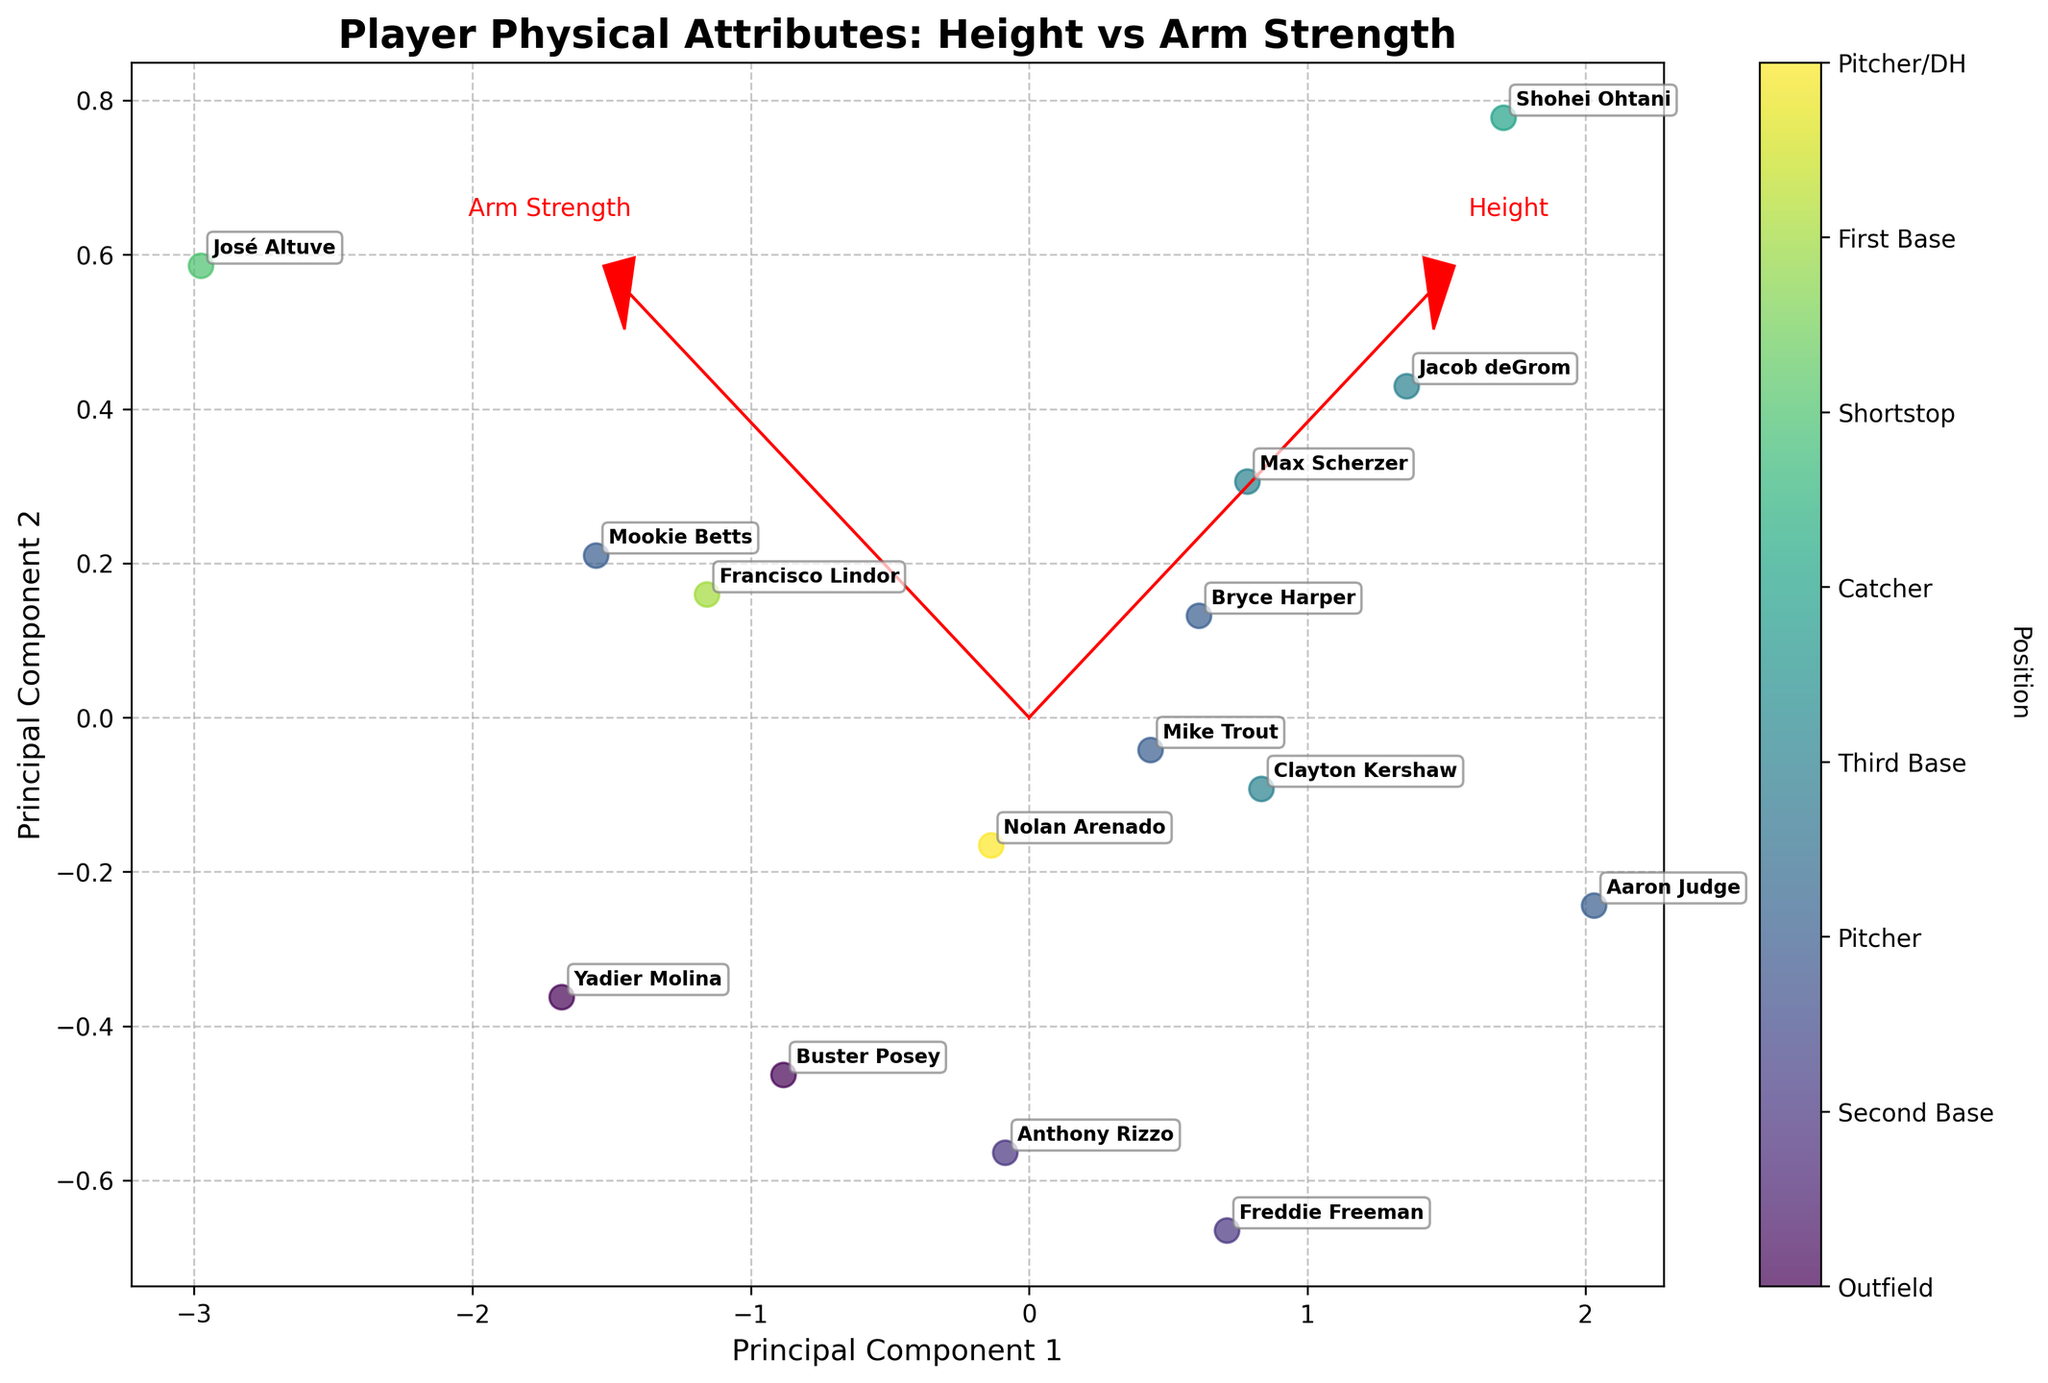What's the title of the figure? The title of the figure is always shown at the top of the plot. In this case, it reads "Player Physical Attributes: Height vs Arm Strength".
Answer: Player Physical Attributes: Height vs Arm Strength How many different player positions are indicated in the plot? Various colors in the plot represent different player positions. Checking the color bar legend, there are 7 unique positions listed.
Answer: 7 Which player has the highest arm strength as visualized in the biplot? By looking at the data points and the associated labels, the player named Shohei Ohtani is positioned highest along the "Arm Strength" eigenvector pointing to the maximum arm strength direction.
Answer: Shohei Ohtani Are there more outfielders or pitchers plotted in the biplot? Checking the color legend and the number of data points for each encoded color representing outfielders and pitchers, there are more outfielders than pitchers. Specifically, outfielders include Mike Trout, Aaron Judge, Mookie Betts, and Bryce Harper, whereas pitchers include Max Scherzer, Clayton Kershaw, and Jacob deGrom.
Answer: Outfielders Which direction on the plot corresponds to increasing height? Eigenvectors and their labels indicate directions. The arrow labeled "Height" points in the direction corresponding to increasing height.
Answer: Rightward How do the heights of First Base players compare with Shortstop players on the biplot? The First Base players (Freddie Freeman and Anthony Rizzo) are plotted further right along the height eigenvector compared to the Shortstop player (Francisco Lindor), indicating that they are taller on average.
Answer: Taller Is arm strength more consistent among pitchers or outfielders? The distribution of data points along the arm strength eigenvector for each position reveals consistency. Outfielders show a wider spread than pitchers who cluster closely around similar arm strength values.
Answer: Pitchers Which position shows the greatest variance in height? Analyzing the spread of data points along the height direction (rightward), catchers (Buster Posey and Yadier Molina) show a considerable variance compared to other positions.
Answer: Catchers What can be said about the two eigenvectors plotted in the biplot? Eigenvectors appear as red arrows indicating the directions of the primary variations in the data. One is labeled "Height" and points rightwards, the other is labeled "Arm Strength" and points upwards.
Answer: Height and Arm Strength Which player has the lowest arm strength? Among the plotted data points and corresponding labels, José Altuve is lowest along the "Arm Strength" eigenvector direction, indicating the minimum arm strength value.
Answer: José Altuve 